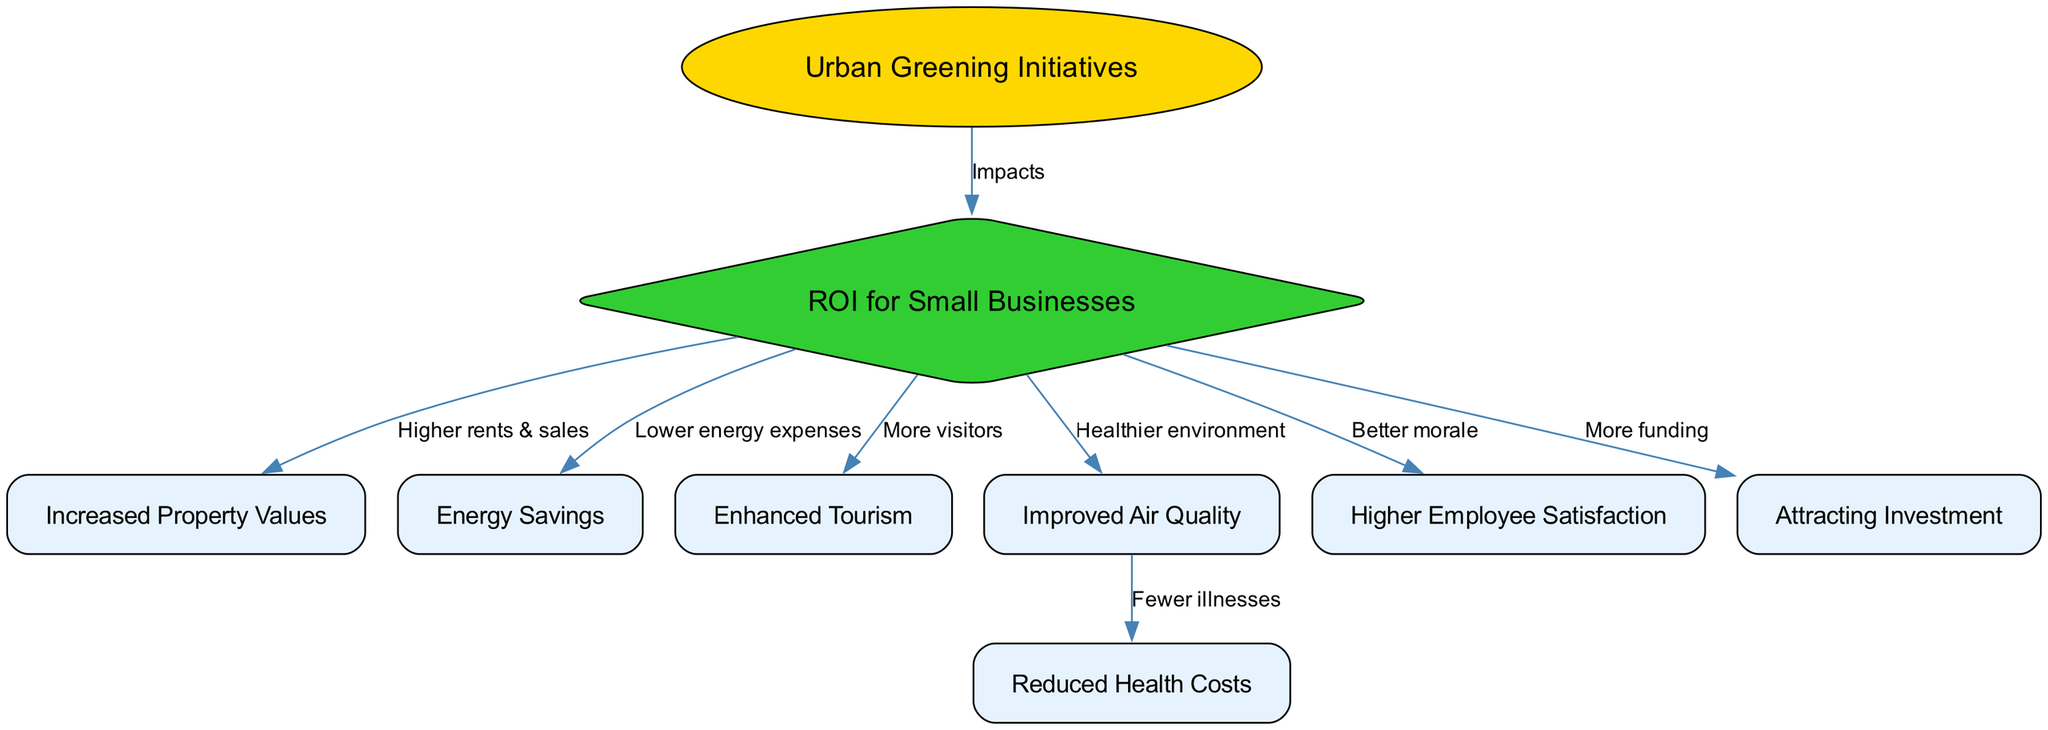What is the main focus of the diagram? The diagram centers on "Urban Greening Initiatives," which is indicated as the root node in the visualization. It serves as the primary concept that connects to various economic benefits represented by other nodes.
Answer: Urban Greening Initiatives How many total nodes are present in the diagram? By counting the nodes listed in the provided data, there are a total of nine nodes, including all aspects related to urban greening and its benefits.
Answer: Nine Which node represents the impact on property values? The node labeled "Increased Property Values" directly shows the financial benefit arising from urban greening initiatives, as indicated by its direct relationship with the ROI for Small Businesses node.
Answer: Increased Property Values What is the relationship between Urban Greening Initiatives and ROI for Small Businesses? The relationship is indicated by an edge labeled "Impacts," showing that Urban Greening Initiatives directly affect the ROI for Small Businesses.
Answer: Impacts Which benefits are more associated with environmental improvements? "Improved Air Quality" and "Reduced Health Costs" indicate benefits that relate to a healthier environment, as they both stem from the improvements noted from urban greening initiatives.
Answer: Improved Air Quality, Reduced Health Costs How does urban greening potentially affect energy expenses for businesses? The diagram shows a direct connection from the ROI for Small Businesses to "Energy Savings," which indicates that urban greening initiatives lead to lower energy expenses for business operations.
Answer: Lower energy expenses What is a consequence of improved air quality as noted in the diagram? The diagram illustrates that improved air quality leads to "Reduced Health Costs," representing a direct benefit for both the community and small businesses from urban greening initiatives.
Answer: Fewer illnesses What is the significance of the "Higher Employee Satisfaction" node? This node is connected to ROI for Small Businesses, demonstrating that urban greening initiatives not only enhance the environment but also contribute to employee morale within these business districts.
Answer: Higher Employee Satisfaction Which node highlights a potential increase in business funding? The "Attracting Investment" node indicates that urban greening can lead to more financial support and investment opportunities for businesses, reflecting an economic benefit related to the greening initiatives.
Answer: More funding 